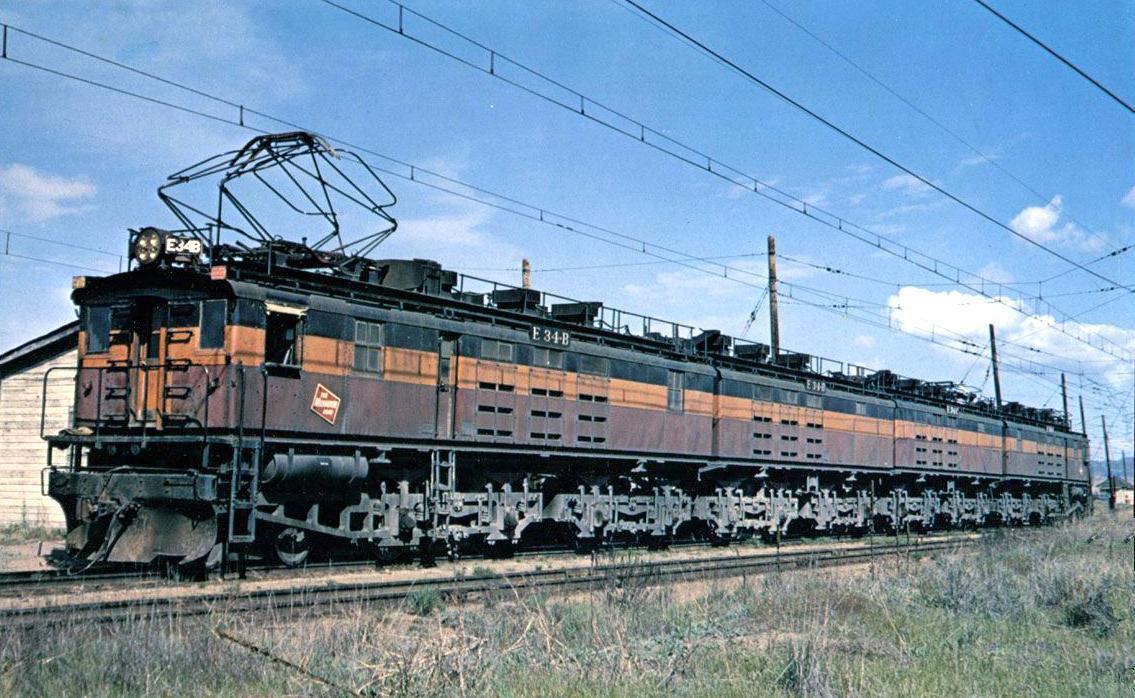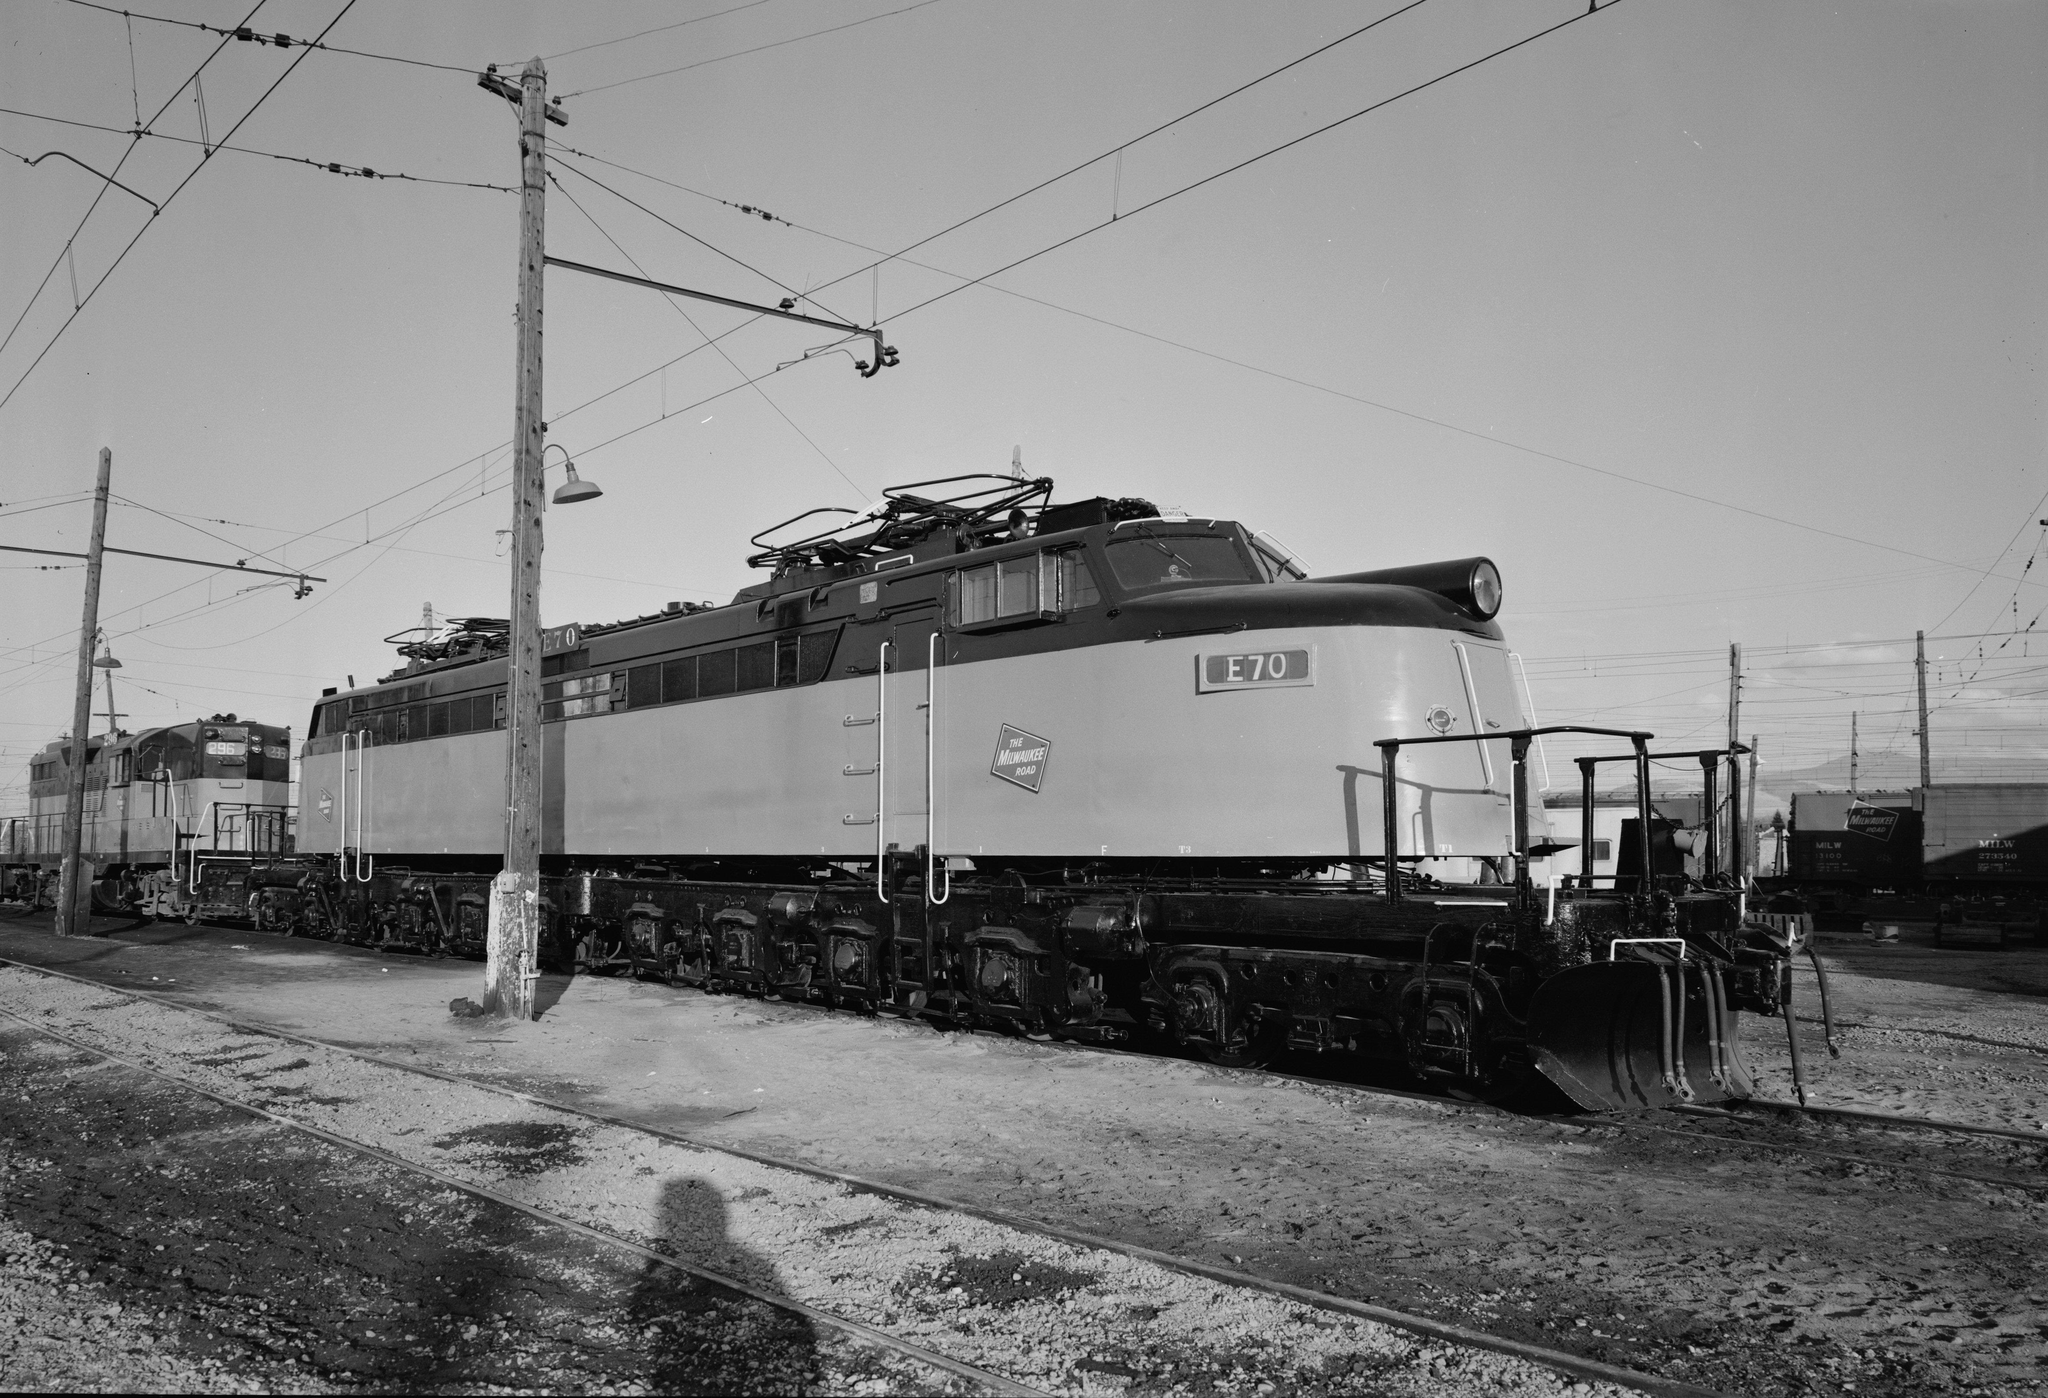The first image is the image on the left, the second image is the image on the right. For the images shown, is this caption "The trains in the right and left images are headed in completely different directions." true? Answer yes or no. Yes. The first image is the image on the left, the second image is the image on the right. Assess this claim about the two images: "None of the trains are near a light pole.". Correct or not? Answer yes or no. No. 